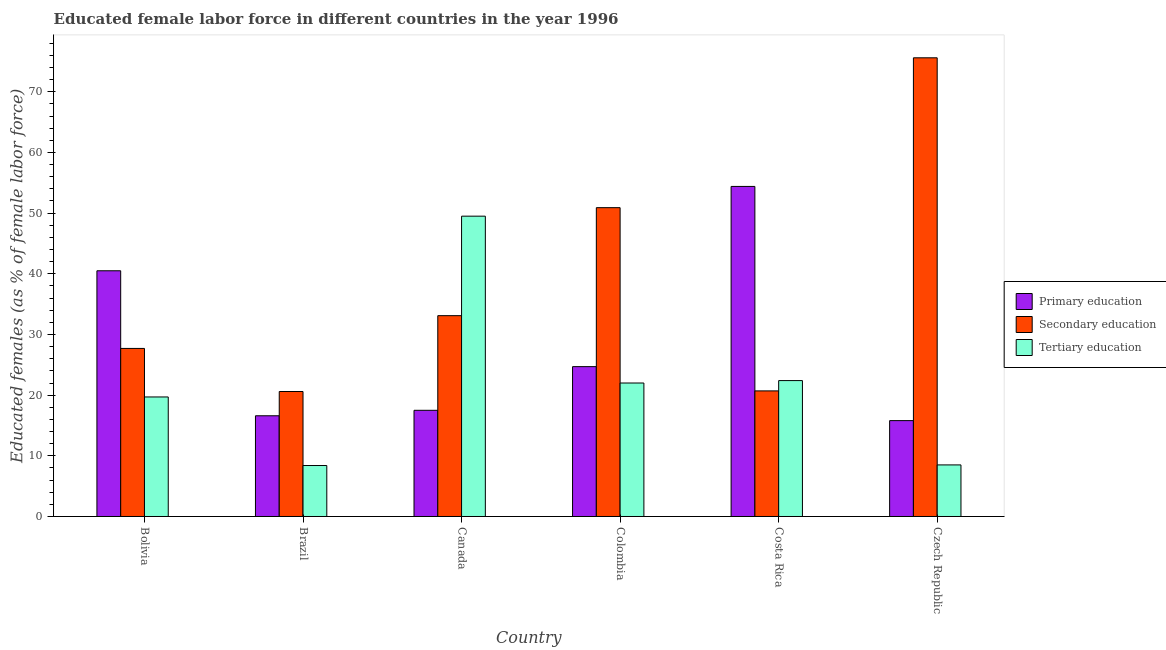Are the number of bars on each tick of the X-axis equal?
Make the answer very short. Yes. How many bars are there on the 3rd tick from the left?
Provide a short and direct response. 3. How many bars are there on the 3rd tick from the right?
Offer a terse response. 3. In how many cases, is the number of bars for a given country not equal to the number of legend labels?
Your answer should be very brief. 0. What is the percentage of female labor force who received tertiary education in Bolivia?
Ensure brevity in your answer.  19.7. Across all countries, what is the maximum percentage of female labor force who received tertiary education?
Your answer should be compact. 49.5. Across all countries, what is the minimum percentage of female labor force who received tertiary education?
Your response must be concise. 8.4. In which country was the percentage of female labor force who received secondary education maximum?
Keep it short and to the point. Czech Republic. In which country was the percentage of female labor force who received tertiary education minimum?
Your answer should be compact. Brazil. What is the total percentage of female labor force who received tertiary education in the graph?
Offer a terse response. 130.5. What is the difference between the percentage of female labor force who received secondary education in Colombia and that in Costa Rica?
Provide a short and direct response. 30.2. What is the difference between the percentage of female labor force who received secondary education in Bolivia and the percentage of female labor force who received tertiary education in Czech Republic?
Keep it short and to the point. 19.2. What is the average percentage of female labor force who received primary education per country?
Your response must be concise. 28.25. What is the difference between the percentage of female labor force who received primary education and percentage of female labor force who received tertiary education in Brazil?
Offer a terse response. 8.2. In how many countries, is the percentage of female labor force who received secondary education greater than 28 %?
Ensure brevity in your answer.  3. What is the ratio of the percentage of female labor force who received primary education in Bolivia to that in Costa Rica?
Your answer should be very brief. 0.74. Is the percentage of female labor force who received tertiary education in Brazil less than that in Czech Republic?
Offer a terse response. Yes. Is the difference between the percentage of female labor force who received tertiary education in Bolivia and Czech Republic greater than the difference between the percentage of female labor force who received primary education in Bolivia and Czech Republic?
Offer a terse response. No. What is the difference between the highest and the second highest percentage of female labor force who received tertiary education?
Offer a very short reply. 27.1. What is the difference between the highest and the lowest percentage of female labor force who received tertiary education?
Give a very brief answer. 41.1. Is the sum of the percentage of female labor force who received secondary education in Brazil and Costa Rica greater than the maximum percentage of female labor force who received tertiary education across all countries?
Make the answer very short. No. What does the 2nd bar from the left in Canada represents?
Give a very brief answer. Secondary education. What does the 2nd bar from the right in Costa Rica represents?
Provide a succinct answer. Secondary education. Are all the bars in the graph horizontal?
Your answer should be very brief. No. Where does the legend appear in the graph?
Offer a very short reply. Center right. How many legend labels are there?
Offer a very short reply. 3. What is the title of the graph?
Ensure brevity in your answer.  Educated female labor force in different countries in the year 1996. Does "Resident buildings and public services" appear as one of the legend labels in the graph?
Your answer should be very brief. No. What is the label or title of the X-axis?
Your answer should be very brief. Country. What is the label or title of the Y-axis?
Provide a succinct answer. Educated females (as % of female labor force). What is the Educated females (as % of female labor force) of Primary education in Bolivia?
Your answer should be very brief. 40.5. What is the Educated females (as % of female labor force) in Secondary education in Bolivia?
Your answer should be compact. 27.7. What is the Educated females (as % of female labor force) in Tertiary education in Bolivia?
Your answer should be compact. 19.7. What is the Educated females (as % of female labor force) of Primary education in Brazil?
Provide a short and direct response. 16.6. What is the Educated females (as % of female labor force) in Secondary education in Brazil?
Ensure brevity in your answer.  20.6. What is the Educated females (as % of female labor force) of Tertiary education in Brazil?
Offer a very short reply. 8.4. What is the Educated females (as % of female labor force) in Secondary education in Canada?
Your answer should be compact. 33.1. What is the Educated females (as % of female labor force) in Tertiary education in Canada?
Offer a terse response. 49.5. What is the Educated females (as % of female labor force) in Primary education in Colombia?
Ensure brevity in your answer.  24.7. What is the Educated females (as % of female labor force) of Secondary education in Colombia?
Give a very brief answer. 50.9. What is the Educated females (as % of female labor force) of Primary education in Costa Rica?
Give a very brief answer. 54.4. What is the Educated females (as % of female labor force) in Secondary education in Costa Rica?
Keep it short and to the point. 20.7. What is the Educated females (as % of female labor force) in Tertiary education in Costa Rica?
Offer a terse response. 22.4. What is the Educated females (as % of female labor force) of Primary education in Czech Republic?
Offer a very short reply. 15.8. What is the Educated females (as % of female labor force) in Secondary education in Czech Republic?
Offer a terse response. 75.6. Across all countries, what is the maximum Educated females (as % of female labor force) in Primary education?
Your response must be concise. 54.4. Across all countries, what is the maximum Educated females (as % of female labor force) in Secondary education?
Provide a succinct answer. 75.6. Across all countries, what is the maximum Educated females (as % of female labor force) in Tertiary education?
Ensure brevity in your answer.  49.5. Across all countries, what is the minimum Educated females (as % of female labor force) in Primary education?
Your answer should be very brief. 15.8. Across all countries, what is the minimum Educated females (as % of female labor force) of Secondary education?
Provide a succinct answer. 20.6. Across all countries, what is the minimum Educated females (as % of female labor force) in Tertiary education?
Offer a very short reply. 8.4. What is the total Educated females (as % of female labor force) of Primary education in the graph?
Your answer should be compact. 169.5. What is the total Educated females (as % of female labor force) of Secondary education in the graph?
Your answer should be very brief. 228.6. What is the total Educated females (as % of female labor force) of Tertiary education in the graph?
Keep it short and to the point. 130.5. What is the difference between the Educated females (as % of female labor force) of Primary education in Bolivia and that in Brazil?
Your response must be concise. 23.9. What is the difference between the Educated females (as % of female labor force) of Secondary education in Bolivia and that in Brazil?
Give a very brief answer. 7.1. What is the difference between the Educated females (as % of female labor force) of Primary education in Bolivia and that in Canada?
Keep it short and to the point. 23. What is the difference between the Educated females (as % of female labor force) in Secondary education in Bolivia and that in Canada?
Your response must be concise. -5.4. What is the difference between the Educated females (as % of female labor force) of Tertiary education in Bolivia and that in Canada?
Offer a terse response. -29.8. What is the difference between the Educated females (as % of female labor force) in Secondary education in Bolivia and that in Colombia?
Offer a very short reply. -23.2. What is the difference between the Educated females (as % of female labor force) of Primary education in Bolivia and that in Czech Republic?
Make the answer very short. 24.7. What is the difference between the Educated females (as % of female labor force) of Secondary education in Bolivia and that in Czech Republic?
Provide a succinct answer. -47.9. What is the difference between the Educated females (as % of female labor force) of Tertiary education in Bolivia and that in Czech Republic?
Keep it short and to the point. 11.2. What is the difference between the Educated females (as % of female labor force) in Primary education in Brazil and that in Canada?
Offer a very short reply. -0.9. What is the difference between the Educated females (as % of female labor force) of Secondary education in Brazil and that in Canada?
Provide a short and direct response. -12.5. What is the difference between the Educated females (as % of female labor force) of Tertiary education in Brazil and that in Canada?
Your response must be concise. -41.1. What is the difference between the Educated females (as % of female labor force) of Primary education in Brazil and that in Colombia?
Provide a succinct answer. -8.1. What is the difference between the Educated females (as % of female labor force) in Secondary education in Brazil and that in Colombia?
Provide a succinct answer. -30.3. What is the difference between the Educated females (as % of female labor force) in Tertiary education in Brazil and that in Colombia?
Your answer should be very brief. -13.6. What is the difference between the Educated females (as % of female labor force) of Primary education in Brazil and that in Costa Rica?
Give a very brief answer. -37.8. What is the difference between the Educated females (as % of female labor force) in Secondary education in Brazil and that in Costa Rica?
Offer a very short reply. -0.1. What is the difference between the Educated females (as % of female labor force) of Secondary education in Brazil and that in Czech Republic?
Offer a very short reply. -55. What is the difference between the Educated females (as % of female labor force) in Tertiary education in Brazil and that in Czech Republic?
Your answer should be compact. -0.1. What is the difference between the Educated females (as % of female labor force) in Primary education in Canada and that in Colombia?
Your answer should be compact. -7.2. What is the difference between the Educated females (as % of female labor force) in Secondary education in Canada and that in Colombia?
Provide a succinct answer. -17.8. What is the difference between the Educated females (as % of female labor force) of Primary education in Canada and that in Costa Rica?
Offer a very short reply. -36.9. What is the difference between the Educated females (as % of female labor force) of Tertiary education in Canada and that in Costa Rica?
Keep it short and to the point. 27.1. What is the difference between the Educated females (as % of female labor force) in Secondary education in Canada and that in Czech Republic?
Provide a succinct answer. -42.5. What is the difference between the Educated females (as % of female labor force) in Primary education in Colombia and that in Costa Rica?
Make the answer very short. -29.7. What is the difference between the Educated females (as % of female labor force) in Secondary education in Colombia and that in Costa Rica?
Your answer should be very brief. 30.2. What is the difference between the Educated females (as % of female labor force) in Primary education in Colombia and that in Czech Republic?
Keep it short and to the point. 8.9. What is the difference between the Educated females (as % of female labor force) in Secondary education in Colombia and that in Czech Republic?
Your answer should be very brief. -24.7. What is the difference between the Educated females (as % of female labor force) of Tertiary education in Colombia and that in Czech Republic?
Make the answer very short. 13.5. What is the difference between the Educated females (as % of female labor force) in Primary education in Costa Rica and that in Czech Republic?
Provide a short and direct response. 38.6. What is the difference between the Educated females (as % of female labor force) of Secondary education in Costa Rica and that in Czech Republic?
Make the answer very short. -54.9. What is the difference between the Educated females (as % of female labor force) in Tertiary education in Costa Rica and that in Czech Republic?
Your response must be concise. 13.9. What is the difference between the Educated females (as % of female labor force) in Primary education in Bolivia and the Educated females (as % of female labor force) in Tertiary education in Brazil?
Keep it short and to the point. 32.1. What is the difference between the Educated females (as % of female labor force) of Secondary education in Bolivia and the Educated females (as % of female labor force) of Tertiary education in Brazil?
Make the answer very short. 19.3. What is the difference between the Educated females (as % of female labor force) in Primary education in Bolivia and the Educated females (as % of female labor force) in Tertiary education in Canada?
Your answer should be very brief. -9. What is the difference between the Educated females (as % of female labor force) in Secondary education in Bolivia and the Educated females (as % of female labor force) in Tertiary education in Canada?
Offer a very short reply. -21.8. What is the difference between the Educated females (as % of female labor force) of Primary education in Bolivia and the Educated females (as % of female labor force) of Secondary education in Colombia?
Make the answer very short. -10.4. What is the difference between the Educated females (as % of female labor force) of Primary education in Bolivia and the Educated females (as % of female labor force) of Secondary education in Costa Rica?
Offer a very short reply. 19.8. What is the difference between the Educated females (as % of female labor force) in Primary education in Bolivia and the Educated females (as % of female labor force) in Tertiary education in Costa Rica?
Provide a short and direct response. 18.1. What is the difference between the Educated females (as % of female labor force) of Primary education in Bolivia and the Educated females (as % of female labor force) of Secondary education in Czech Republic?
Ensure brevity in your answer.  -35.1. What is the difference between the Educated females (as % of female labor force) in Primary education in Bolivia and the Educated females (as % of female labor force) in Tertiary education in Czech Republic?
Your answer should be compact. 32. What is the difference between the Educated females (as % of female labor force) of Secondary education in Bolivia and the Educated females (as % of female labor force) of Tertiary education in Czech Republic?
Offer a terse response. 19.2. What is the difference between the Educated females (as % of female labor force) in Primary education in Brazil and the Educated females (as % of female labor force) in Secondary education in Canada?
Make the answer very short. -16.5. What is the difference between the Educated females (as % of female labor force) of Primary education in Brazil and the Educated females (as % of female labor force) of Tertiary education in Canada?
Make the answer very short. -32.9. What is the difference between the Educated females (as % of female labor force) in Secondary education in Brazil and the Educated females (as % of female labor force) in Tertiary education in Canada?
Make the answer very short. -28.9. What is the difference between the Educated females (as % of female labor force) of Primary education in Brazil and the Educated females (as % of female labor force) of Secondary education in Colombia?
Provide a succinct answer. -34.3. What is the difference between the Educated females (as % of female labor force) in Secondary education in Brazil and the Educated females (as % of female labor force) in Tertiary education in Colombia?
Your answer should be very brief. -1.4. What is the difference between the Educated females (as % of female labor force) of Primary education in Brazil and the Educated females (as % of female labor force) of Tertiary education in Costa Rica?
Make the answer very short. -5.8. What is the difference between the Educated females (as % of female labor force) of Secondary education in Brazil and the Educated females (as % of female labor force) of Tertiary education in Costa Rica?
Offer a terse response. -1.8. What is the difference between the Educated females (as % of female labor force) of Primary education in Brazil and the Educated females (as % of female labor force) of Secondary education in Czech Republic?
Your answer should be compact. -59. What is the difference between the Educated females (as % of female labor force) of Primary education in Brazil and the Educated females (as % of female labor force) of Tertiary education in Czech Republic?
Provide a short and direct response. 8.1. What is the difference between the Educated females (as % of female labor force) of Primary education in Canada and the Educated females (as % of female labor force) of Secondary education in Colombia?
Your answer should be compact. -33.4. What is the difference between the Educated females (as % of female labor force) of Primary education in Canada and the Educated females (as % of female labor force) of Tertiary education in Colombia?
Provide a succinct answer. -4.5. What is the difference between the Educated females (as % of female labor force) of Secondary education in Canada and the Educated females (as % of female labor force) of Tertiary education in Colombia?
Make the answer very short. 11.1. What is the difference between the Educated females (as % of female labor force) of Primary education in Canada and the Educated females (as % of female labor force) of Secondary education in Costa Rica?
Ensure brevity in your answer.  -3.2. What is the difference between the Educated females (as % of female labor force) of Primary education in Canada and the Educated females (as % of female labor force) of Tertiary education in Costa Rica?
Ensure brevity in your answer.  -4.9. What is the difference between the Educated females (as % of female labor force) of Secondary education in Canada and the Educated females (as % of female labor force) of Tertiary education in Costa Rica?
Offer a very short reply. 10.7. What is the difference between the Educated females (as % of female labor force) in Primary education in Canada and the Educated females (as % of female labor force) in Secondary education in Czech Republic?
Offer a terse response. -58.1. What is the difference between the Educated females (as % of female labor force) of Primary education in Canada and the Educated females (as % of female labor force) of Tertiary education in Czech Republic?
Offer a very short reply. 9. What is the difference between the Educated females (as % of female labor force) in Secondary education in Canada and the Educated females (as % of female labor force) in Tertiary education in Czech Republic?
Offer a very short reply. 24.6. What is the difference between the Educated females (as % of female labor force) of Primary education in Colombia and the Educated females (as % of female labor force) of Secondary education in Costa Rica?
Give a very brief answer. 4. What is the difference between the Educated females (as % of female labor force) in Primary education in Colombia and the Educated females (as % of female labor force) in Secondary education in Czech Republic?
Make the answer very short. -50.9. What is the difference between the Educated females (as % of female labor force) in Secondary education in Colombia and the Educated females (as % of female labor force) in Tertiary education in Czech Republic?
Offer a terse response. 42.4. What is the difference between the Educated females (as % of female labor force) of Primary education in Costa Rica and the Educated females (as % of female labor force) of Secondary education in Czech Republic?
Provide a succinct answer. -21.2. What is the difference between the Educated females (as % of female labor force) in Primary education in Costa Rica and the Educated females (as % of female labor force) in Tertiary education in Czech Republic?
Provide a succinct answer. 45.9. What is the difference between the Educated females (as % of female labor force) of Secondary education in Costa Rica and the Educated females (as % of female labor force) of Tertiary education in Czech Republic?
Provide a succinct answer. 12.2. What is the average Educated females (as % of female labor force) of Primary education per country?
Your answer should be very brief. 28.25. What is the average Educated females (as % of female labor force) in Secondary education per country?
Give a very brief answer. 38.1. What is the average Educated females (as % of female labor force) of Tertiary education per country?
Provide a succinct answer. 21.75. What is the difference between the Educated females (as % of female labor force) in Primary education and Educated females (as % of female labor force) in Secondary education in Bolivia?
Ensure brevity in your answer.  12.8. What is the difference between the Educated females (as % of female labor force) in Primary education and Educated females (as % of female labor force) in Tertiary education in Bolivia?
Ensure brevity in your answer.  20.8. What is the difference between the Educated females (as % of female labor force) in Primary education and Educated females (as % of female labor force) in Secondary education in Brazil?
Provide a succinct answer. -4. What is the difference between the Educated females (as % of female labor force) of Primary education and Educated females (as % of female labor force) of Secondary education in Canada?
Ensure brevity in your answer.  -15.6. What is the difference between the Educated females (as % of female labor force) of Primary education and Educated females (as % of female labor force) of Tertiary education in Canada?
Keep it short and to the point. -32. What is the difference between the Educated females (as % of female labor force) of Secondary education and Educated females (as % of female labor force) of Tertiary education in Canada?
Make the answer very short. -16.4. What is the difference between the Educated females (as % of female labor force) of Primary education and Educated females (as % of female labor force) of Secondary education in Colombia?
Ensure brevity in your answer.  -26.2. What is the difference between the Educated females (as % of female labor force) in Secondary education and Educated females (as % of female labor force) in Tertiary education in Colombia?
Give a very brief answer. 28.9. What is the difference between the Educated females (as % of female labor force) of Primary education and Educated females (as % of female labor force) of Secondary education in Costa Rica?
Offer a terse response. 33.7. What is the difference between the Educated females (as % of female labor force) in Primary education and Educated females (as % of female labor force) in Secondary education in Czech Republic?
Your answer should be compact. -59.8. What is the difference between the Educated females (as % of female labor force) of Secondary education and Educated females (as % of female labor force) of Tertiary education in Czech Republic?
Make the answer very short. 67.1. What is the ratio of the Educated females (as % of female labor force) of Primary education in Bolivia to that in Brazil?
Ensure brevity in your answer.  2.44. What is the ratio of the Educated females (as % of female labor force) of Secondary education in Bolivia to that in Brazil?
Your answer should be compact. 1.34. What is the ratio of the Educated females (as % of female labor force) in Tertiary education in Bolivia to that in Brazil?
Keep it short and to the point. 2.35. What is the ratio of the Educated females (as % of female labor force) in Primary education in Bolivia to that in Canada?
Provide a short and direct response. 2.31. What is the ratio of the Educated females (as % of female labor force) of Secondary education in Bolivia to that in Canada?
Offer a terse response. 0.84. What is the ratio of the Educated females (as % of female labor force) in Tertiary education in Bolivia to that in Canada?
Your response must be concise. 0.4. What is the ratio of the Educated females (as % of female labor force) in Primary education in Bolivia to that in Colombia?
Give a very brief answer. 1.64. What is the ratio of the Educated females (as % of female labor force) of Secondary education in Bolivia to that in Colombia?
Your answer should be compact. 0.54. What is the ratio of the Educated females (as % of female labor force) in Tertiary education in Bolivia to that in Colombia?
Your answer should be very brief. 0.9. What is the ratio of the Educated females (as % of female labor force) in Primary education in Bolivia to that in Costa Rica?
Your answer should be compact. 0.74. What is the ratio of the Educated females (as % of female labor force) in Secondary education in Bolivia to that in Costa Rica?
Keep it short and to the point. 1.34. What is the ratio of the Educated females (as % of female labor force) in Tertiary education in Bolivia to that in Costa Rica?
Your answer should be very brief. 0.88. What is the ratio of the Educated females (as % of female labor force) of Primary education in Bolivia to that in Czech Republic?
Offer a very short reply. 2.56. What is the ratio of the Educated females (as % of female labor force) of Secondary education in Bolivia to that in Czech Republic?
Offer a very short reply. 0.37. What is the ratio of the Educated females (as % of female labor force) of Tertiary education in Bolivia to that in Czech Republic?
Keep it short and to the point. 2.32. What is the ratio of the Educated females (as % of female labor force) in Primary education in Brazil to that in Canada?
Offer a terse response. 0.95. What is the ratio of the Educated females (as % of female labor force) in Secondary education in Brazil to that in Canada?
Your response must be concise. 0.62. What is the ratio of the Educated females (as % of female labor force) of Tertiary education in Brazil to that in Canada?
Offer a very short reply. 0.17. What is the ratio of the Educated females (as % of female labor force) of Primary education in Brazil to that in Colombia?
Provide a succinct answer. 0.67. What is the ratio of the Educated females (as % of female labor force) of Secondary education in Brazil to that in Colombia?
Your answer should be very brief. 0.4. What is the ratio of the Educated females (as % of female labor force) in Tertiary education in Brazil to that in Colombia?
Make the answer very short. 0.38. What is the ratio of the Educated females (as % of female labor force) in Primary education in Brazil to that in Costa Rica?
Your answer should be compact. 0.31. What is the ratio of the Educated females (as % of female labor force) of Primary education in Brazil to that in Czech Republic?
Your answer should be very brief. 1.05. What is the ratio of the Educated females (as % of female labor force) in Secondary education in Brazil to that in Czech Republic?
Your response must be concise. 0.27. What is the ratio of the Educated females (as % of female labor force) of Tertiary education in Brazil to that in Czech Republic?
Your answer should be compact. 0.99. What is the ratio of the Educated females (as % of female labor force) of Primary education in Canada to that in Colombia?
Your response must be concise. 0.71. What is the ratio of the Educated females (as % of female labor force) in Secondary education in Canada to that in Colombia?
Offer a terse response. 0.65. What is the ratio of the Educated females (as % of female labor force) of Tertiary education in Canada to that in Colombia?
Your response must be concise. 2.25. What is the ratio of the Educated females (as % of female labor force) in Primary education in Canada to that in Costa Rica?
Your answer should be compact. 0.32. What is the ratio of the Educated females (as % of female labor force) of Secondary education in Canada to that in Costa Rica?
Offer a terse response. 1.6. What is the ratio of the Educated females (as % of female labor force) of Tertiary education in Canada to that in Costa Rica?
Your response must be concise. 2.21. What is the ratio of the Educated females (as % of female labor force) of Primary education in Canada to that in Czech Republic?
Offer a very short reply. 1.11. What is the ratio of the Educated females (as % of female labor force) in Secondary education in Canada to that in Czech Republic?
Make the answer very short. 0.44. What is the ratio of the Educated females (as % of female labor force) of Tertiary education in Canada to that in Czech Republic?
Offer a very short reply. 5.82. What is the ratio of the Educated females (as % of female labor force) of Primary education in Colombia to that in Costa Rica?
Provide a short and direct response. 0.45. What is the ratio of the Educated females (as % of female labor force) in Secondary education in Colombia to that in Costa Rica?
Your answer should be compact. 2.46. What is the ratio of the Educated females (as % of female labor force) in Tertiary education in Colombia to that in Costa Rica?
Provide a succinct answer. 0.98. What is the ratio of the Educated females (as % of female labor force) of Primary education in Colombia to that in Czech Republic?
Your response must be concise. 1.56. What is the ratio of the Educated females (as % of female labor force) in Secondary education in Colombia to that in Czech Republic?
Your response must be concise. 0.67. What is the ratio of the Educated females (as % of female labor force) of Tertiary education in Colombia to that in Czech Republic?
Make the answer very short. 2.59. What is the ratio of the Educated females (as % of female labor force) in Primary education in Costa Rica to that in Czech Republic?
Ensure brevity in your answer.  3.44. What is the ratio of the Educated females (as % of female labor force) in Secondary education in Costa Rica to that in Czech Republic?
Offer a terse response. 0.27. What is the ratio of the Educated females (as % of female labor force) of Tertiary education in Costa Rica to that in Czech Republic?
Offer a very short reply. 2.64. What is the difference between the highest and the second highest Educated females (as % of female labor force) in Primary education?
Keep it short and to the point. 13.9. What is the difference between the highest and the second highest Educated females (as % of female labor force) of Secondary education?
Offer a terse response. 24.7. What is the difference between the highest and the second highest Educated females (as % of female labor force) of Tertiary education?
Keep it short and to the point. 27.1. What is the difference between the highest and the lowest Educated females (as % of female labor force) of Primary education?
Provide a short and direct response. 38.6. What is the difference between the highest and the lowest Educated females (as % of female labor force) of Secondary education?
Provide a short and direct response. 55. What is the difference between the highest and the lowest Educated females (as % of female labor force) of Tertiary education?
Provide a succinct answer. 41.1. 